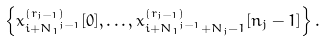Convert formula to latex. <formula><loc_0><loc_0><loc_500><loc_500>\left \{ x _ { i + { N _ { 1 } } ^ { j - 1 } } ^ { ( r _ { j - 1 } ) } [ 0 ] , \dots , x _ { i + { N _ { 1 } } ^ { j - 1 } + N _ { j } - 1 } ^ { ( r _ { j - 1 } ) } [ n _ { j } - 1 ] \right \} .</formula> 